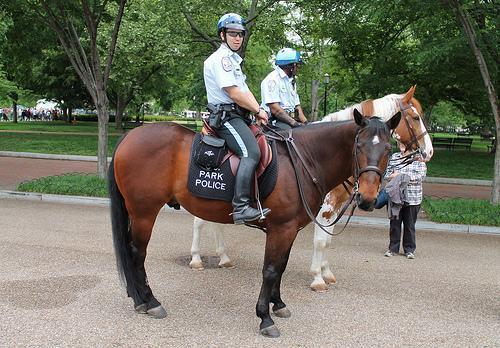How many horse?
Give a very brief answer. 2. 